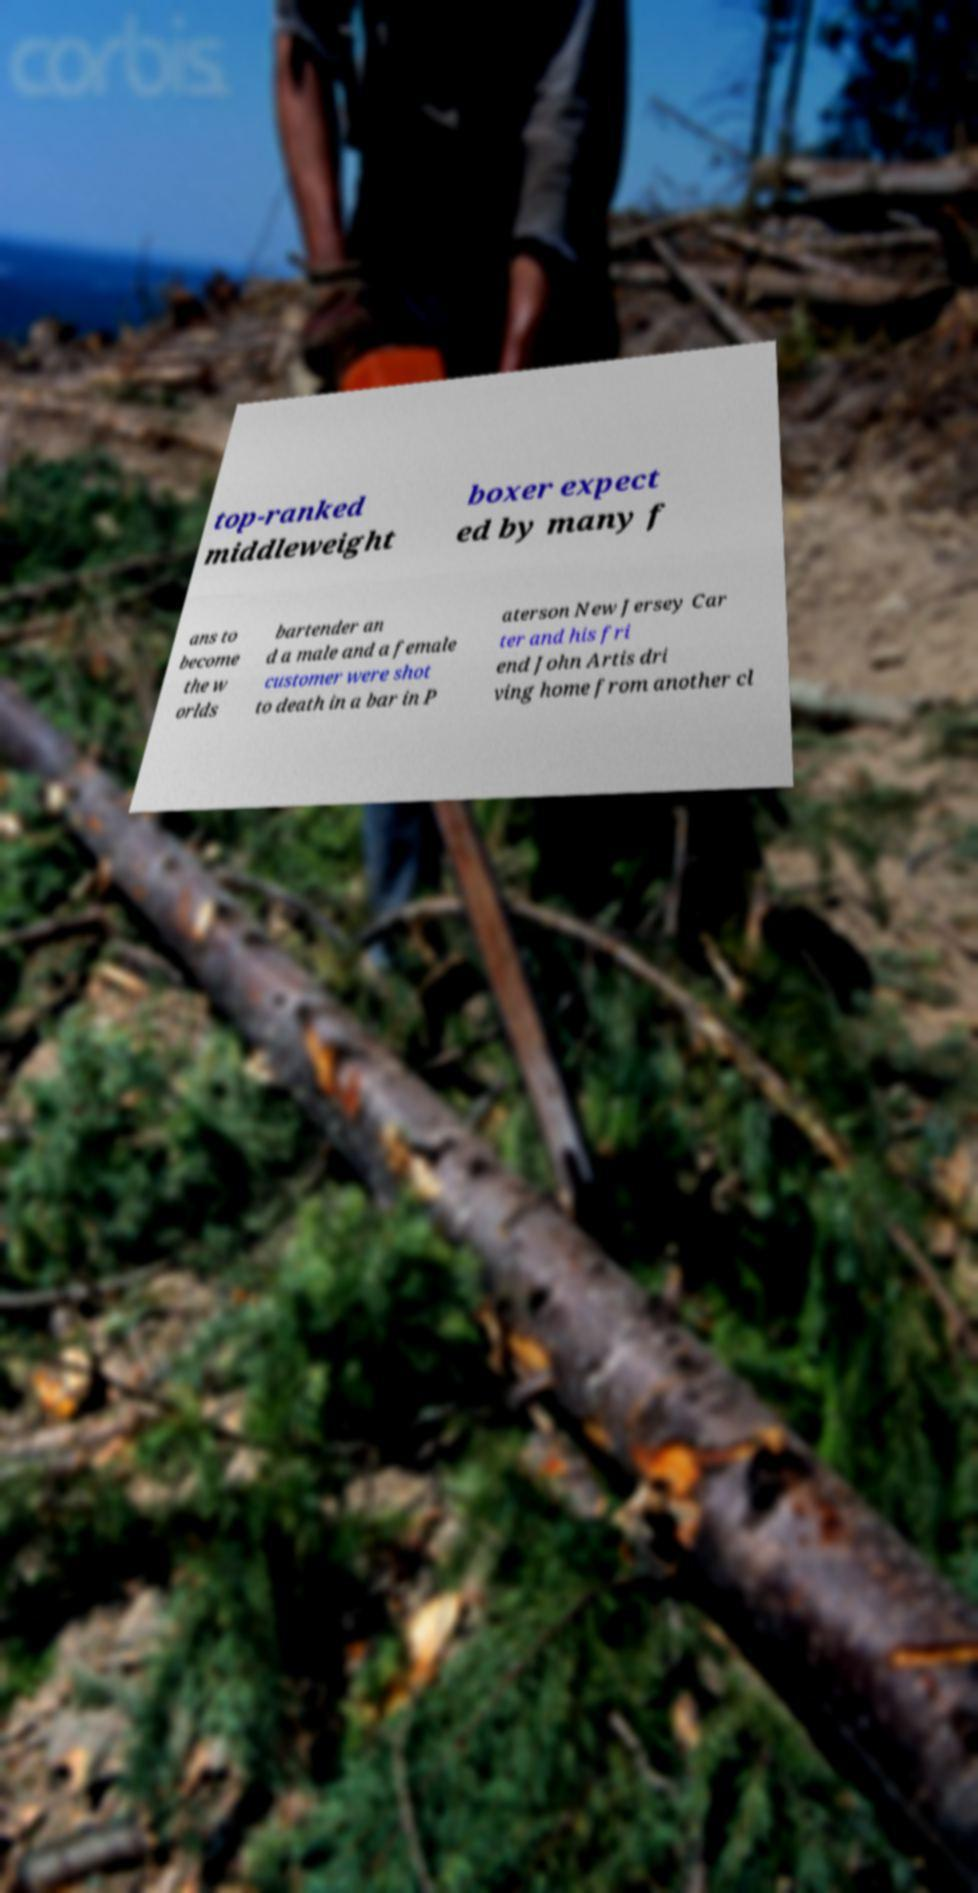Can you accurately transcribe the text from the provided image for me? top-ranked middleweight boxer expect ed by many f ans to become the w orlds bartender an d a male and a female customer were shot to death in a bar in P aterson New Jersey Car ter and his fri end John Artis dri ving home from another cl 